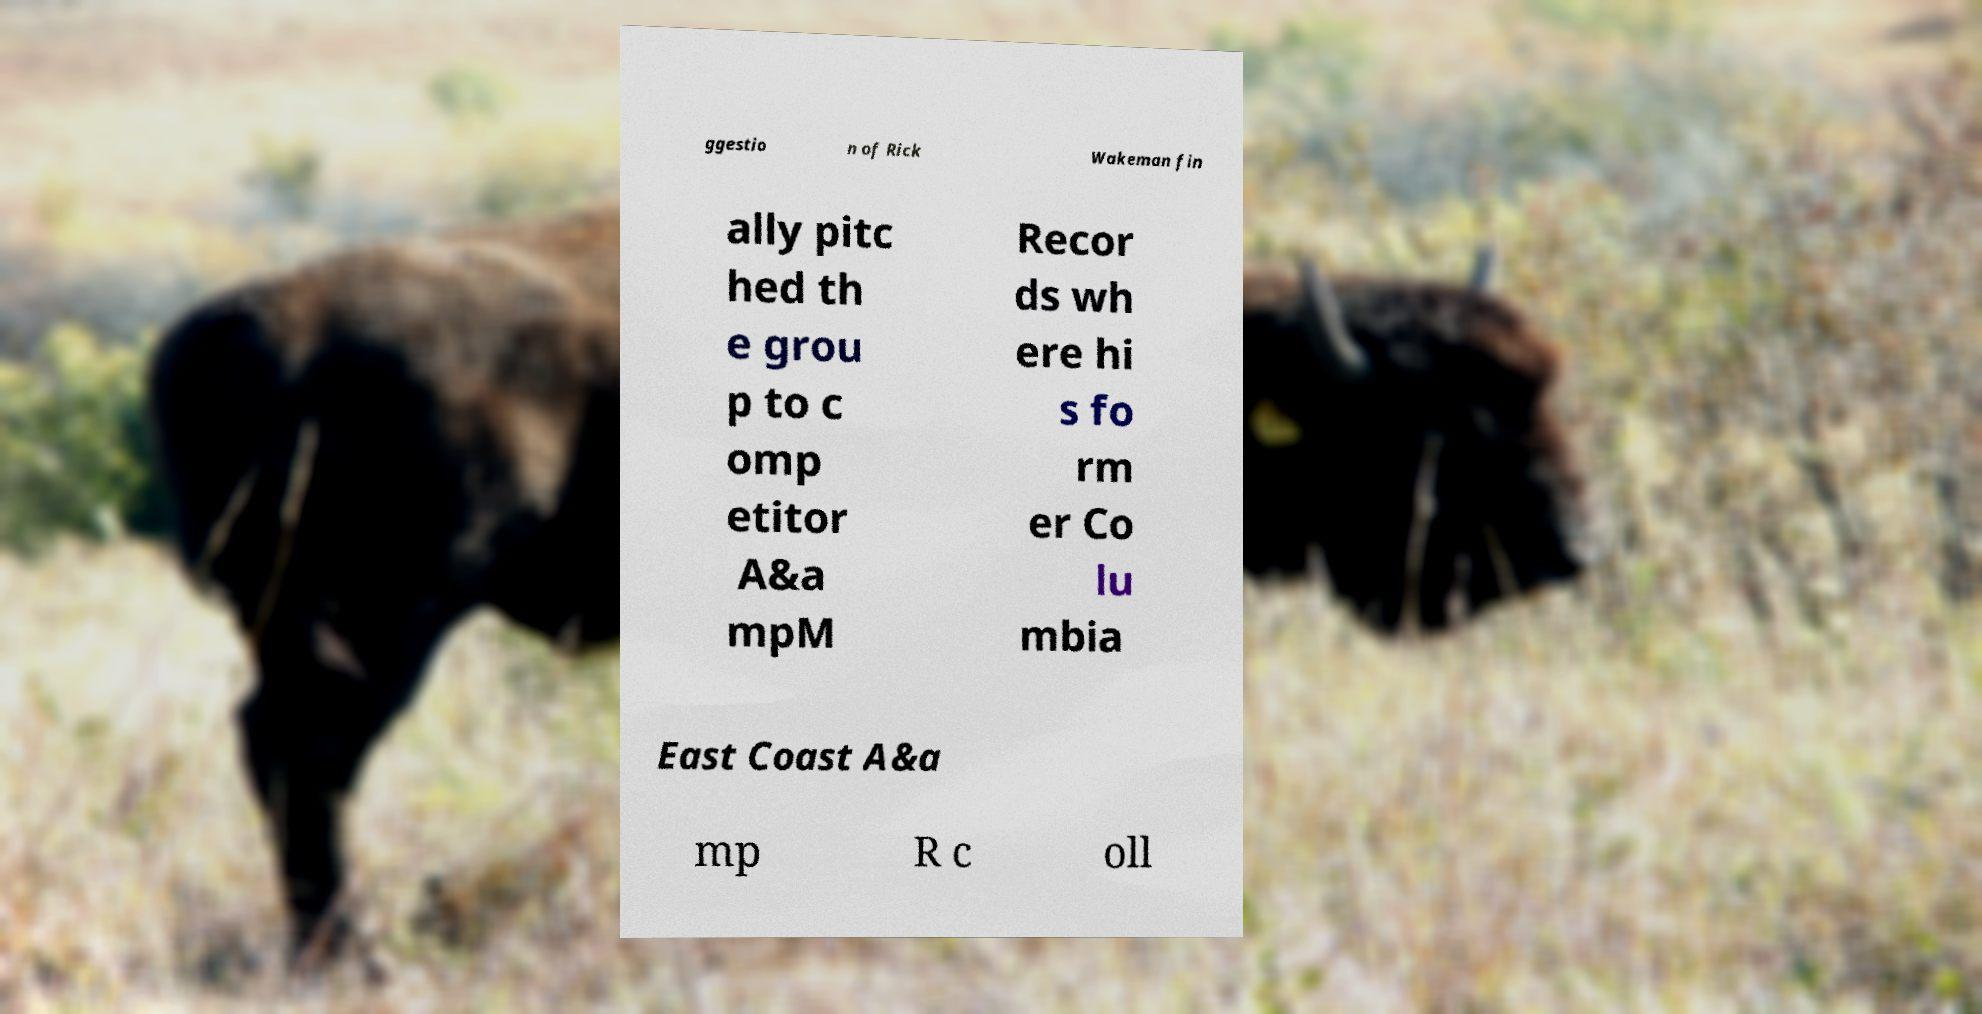Please read and relay the text visible in this image. What does it say? ggestio n of Rick Wakeman fin ally pitc hed th e grou p to c omp etitor A&a mpM Recor ds wh ere hi s fo rm er Co lu mbia East Coast A&a mp R c oll 